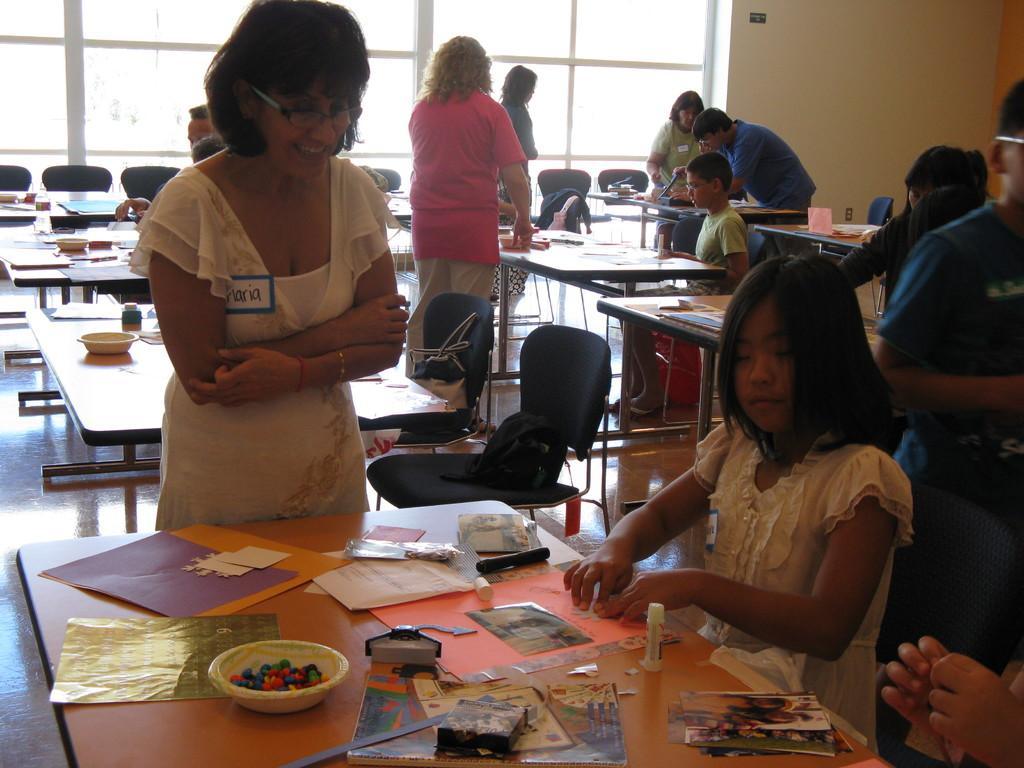Describe this image in one or two sentences. In this picture there is a girl sitting in the chair in front of a table on which some of the accessories were placed like charts, glue stick. In front of the table there is a woman standing and smiling. In the background, there are some people standing. We can observe a windows and a wall here. 